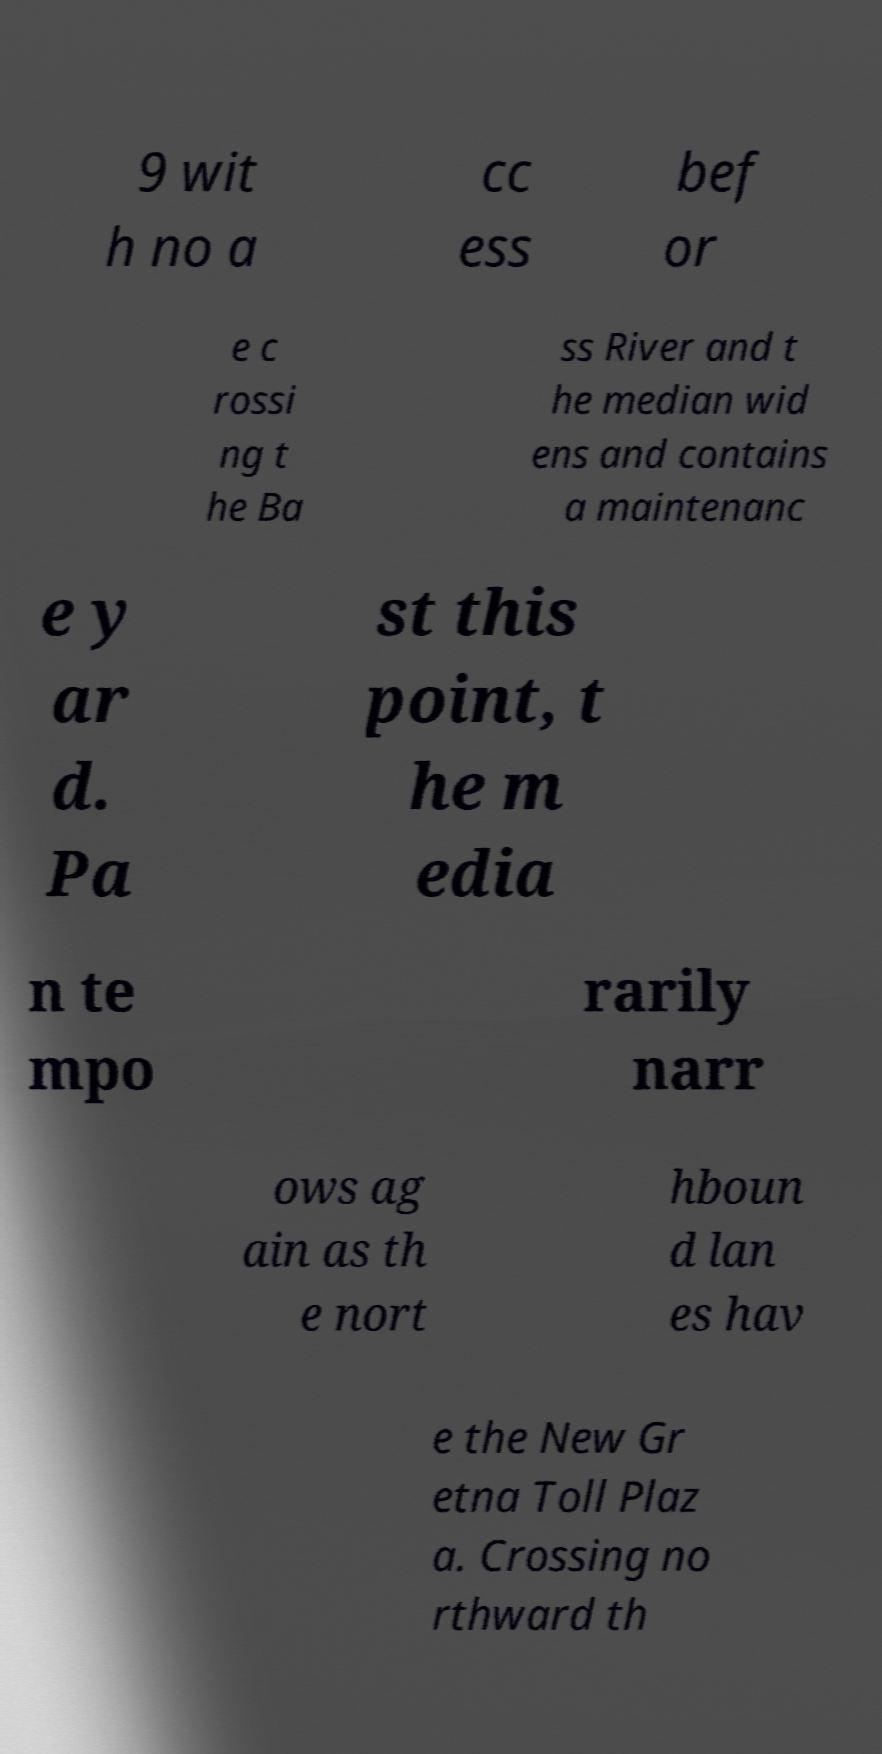Please identify and transcribe the text found in this image. 9 wit h no a cc ess bef or e c rossi ng t he Ba ss River and t he median wid ens and contains a maintenanc e y ar d. Pa st this point, t he m edia n te mpo rarily narr ows ag ain as th e nort hboun d lan es hav e the New Gr etna Toll Plaz a. Crossing no rthward th 